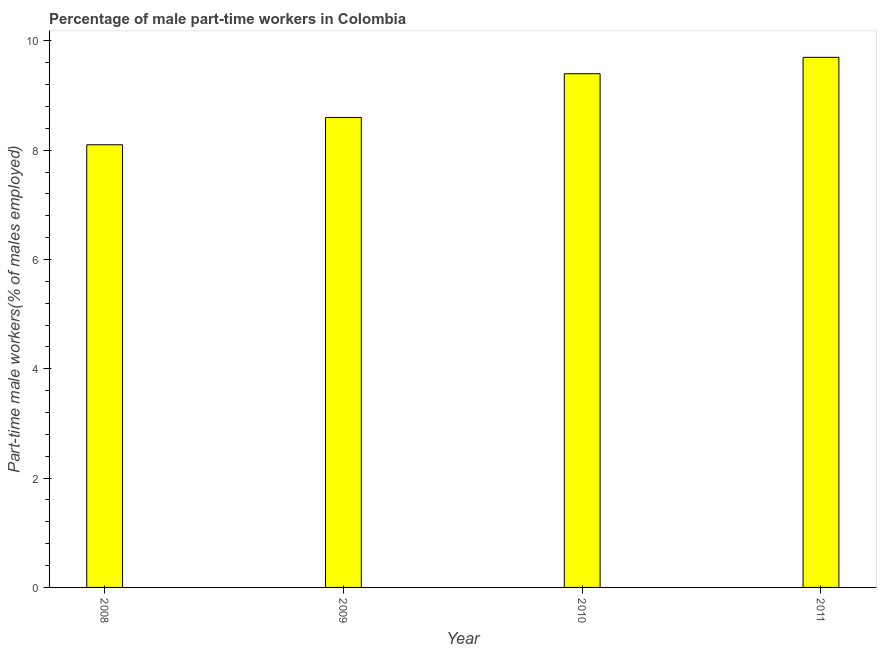Does the graph contain grids?
Offer a very short reply. No. What is the title of the graph?
Keep it short and to the point. Percentage of male part-time workers in Colombia. What is the label or title of the Y-axis?
Keep it short and to the point. Part-time male workers(% of males employed). What is the percentage of part-time male workers in 2008?
Provide a succinct answer. 8.1. Across all years, what is the maximum percentage of part-time male workers?
Your answer should be very brief. 9.7. Across all years, what is the minimum percentage of part-time male workers?
Provide a succinct answer. 8.1. In which year was the percentage of part-time male workers maximum?
Your answer should be very brief. 2011. What is the sum of the percentage of part-time male workers?
Ensure brevity in your answer.  35.8. What is the average percentage of part-time male workers per year?
Your answer should be compact. 8.95. What is the median percentage of part-time male workers?
Provide a short and direct response. 9. What is the ratio of the percentage of part-time male workers in 2008 to that in 2010?
Give a very brief answer. 0.86. Is the percentage of part-time male workers in 2010 less than that in 2011?
Offer a very short reply. Yes. What is the difference between the highest and the second highest percentage of part-time male workers?
Make the answer very short. 0.3. Is the sum of the percentage of part-time male workers in 2008 and 2009 greater than the maximum percentage of part-time male workers across all years?
Offer a terse response. Yes. What is the difference between the highest and the lowest percentage of part-time male workers?
Provide a succinct answer. 1.6. In how many years, is the percentage of part-time male workers greater than the average percentage of part-time male workers taken over all years?
Provide a short and direct response. 2. How many bars are there?
Your response must be concise. 4. How many years are there in the graph?
Provide a short and direct response. 4. Are the values on the major ticks of Y-axis written in scientific E-notation?
Offer a terse response. No. What is the Part-time male workers(% of males employed) of 2008?
Provide a succinct answer. 8.1. What is the Part-time male workers(% of males employed) in 2009?
Provide a short and direct response. 8.6. What is the Part-time male workers(% of males employed) in 2010?
Offer a very short reply. 9.4. What is the Part-time male workers(% of males employed) of 2011?
Provide a short and direct response. 9.7. What is the difference between the Part-time male workers(% of males employed) in 2008 and 2009?
Your response must be concise. -0.5. What is the difference between the Part-time male workers(% of males employed) in 2008 and 2010?
Your answer should be compact. -1.3. What is the difference between the Part-time male workers(% of males employed) in 2008 and 2011?
Provide a succinct answer. -1.6. What is the ratio of the Part-time male workers(% of males employed) in 2008 to that in 2009?
Provide a short and direct response. 0.94. What is the ratio of the Part-time male workers(% of males employed) in 2008 to that in 2010?
Provide a short and direct response. 0.86. What is the ratio of the Part-time male workers(% of males employed) in 2008 to that in 2011?
Your answer should be very brief. 0.83. What is the ratio of the Part-time male workers(% of males employed) in 2009 to that in 2010?
Provide a succinct answer. 0.92. What is the ratio of the Part-time male workers(% of males employed) in 2009 to that in 2011?
Give a very brief answer. 0.89. What is the ratio of the Part-time male workers(% of males employed) in 2010 to that in 2011?
Provide a succinct answer. 0.97. 